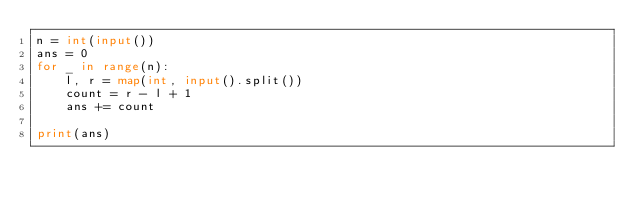<code> <loc_0><loc_0><loc_500><loc_500><_Python_>n = int(input())
ans = 0
for _ in range(n):
    l, r = map(int, input().split())
    count = r - l + 1
    ans += count

print(ans)</code> 